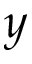<formula> <loc_0><loc_0><loc_500><loc_500>y</formula> 